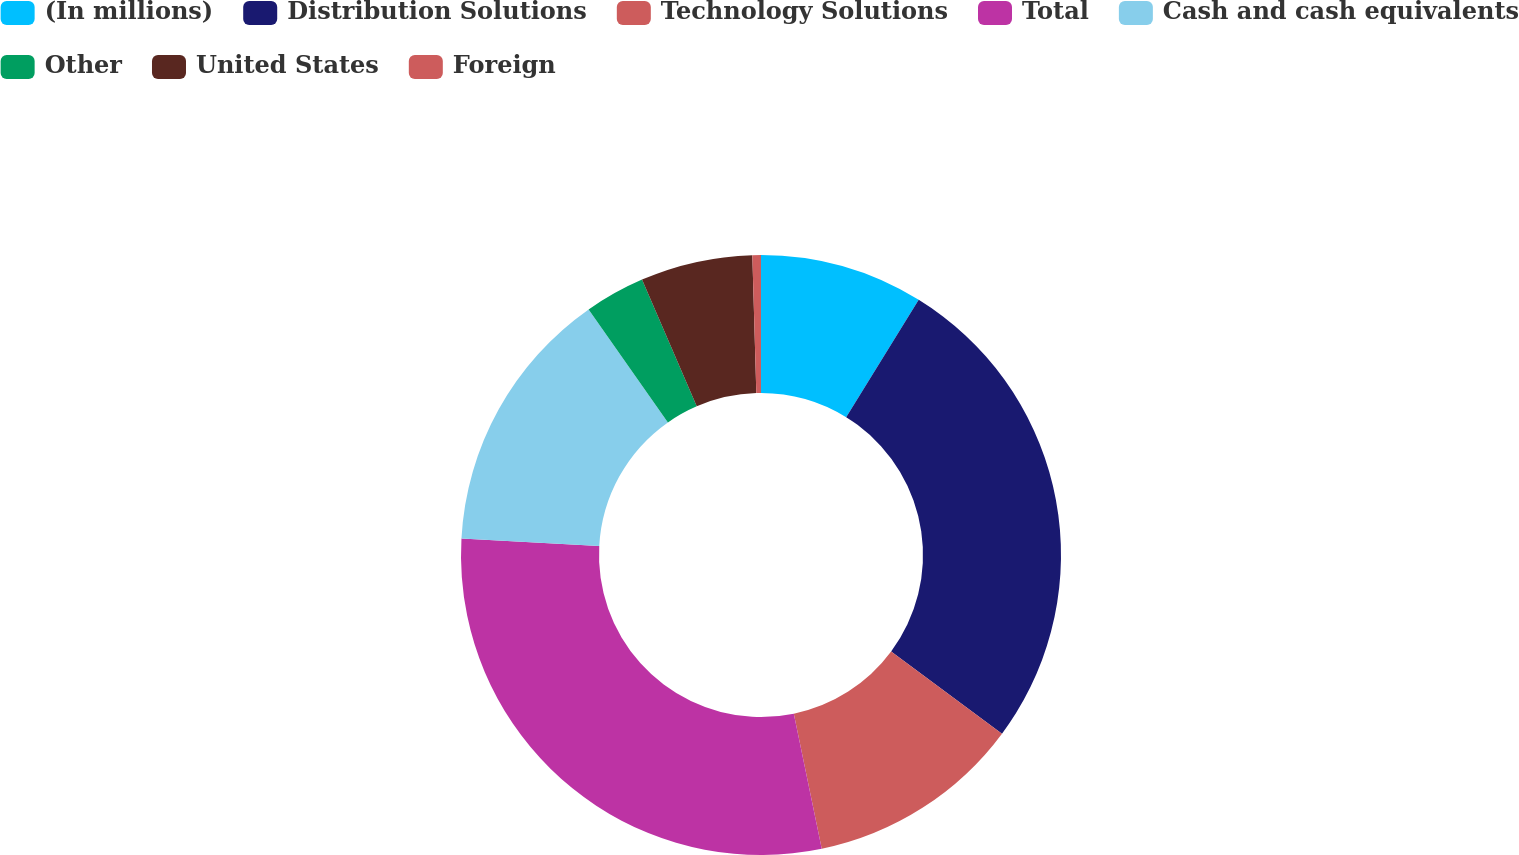Convert chart. <chart><loc_0><loc_0><loc_500><loc_500><pie_chart><fcel>(In millions)<fcel>Distribution Solutions<fcel>Technology Solutions<fcel>Total<fcel>Cash and cash equivalents<fcel>Other<fcel>United States<fcel>Foreign<nl><fcel>8.81%<fcel>26.34%<fcel>11.6%<fcel>29.12%<fcel>14.38%<fcel>3.25%<fcel>6.03%<fcel>0.46%<nl></chart> 